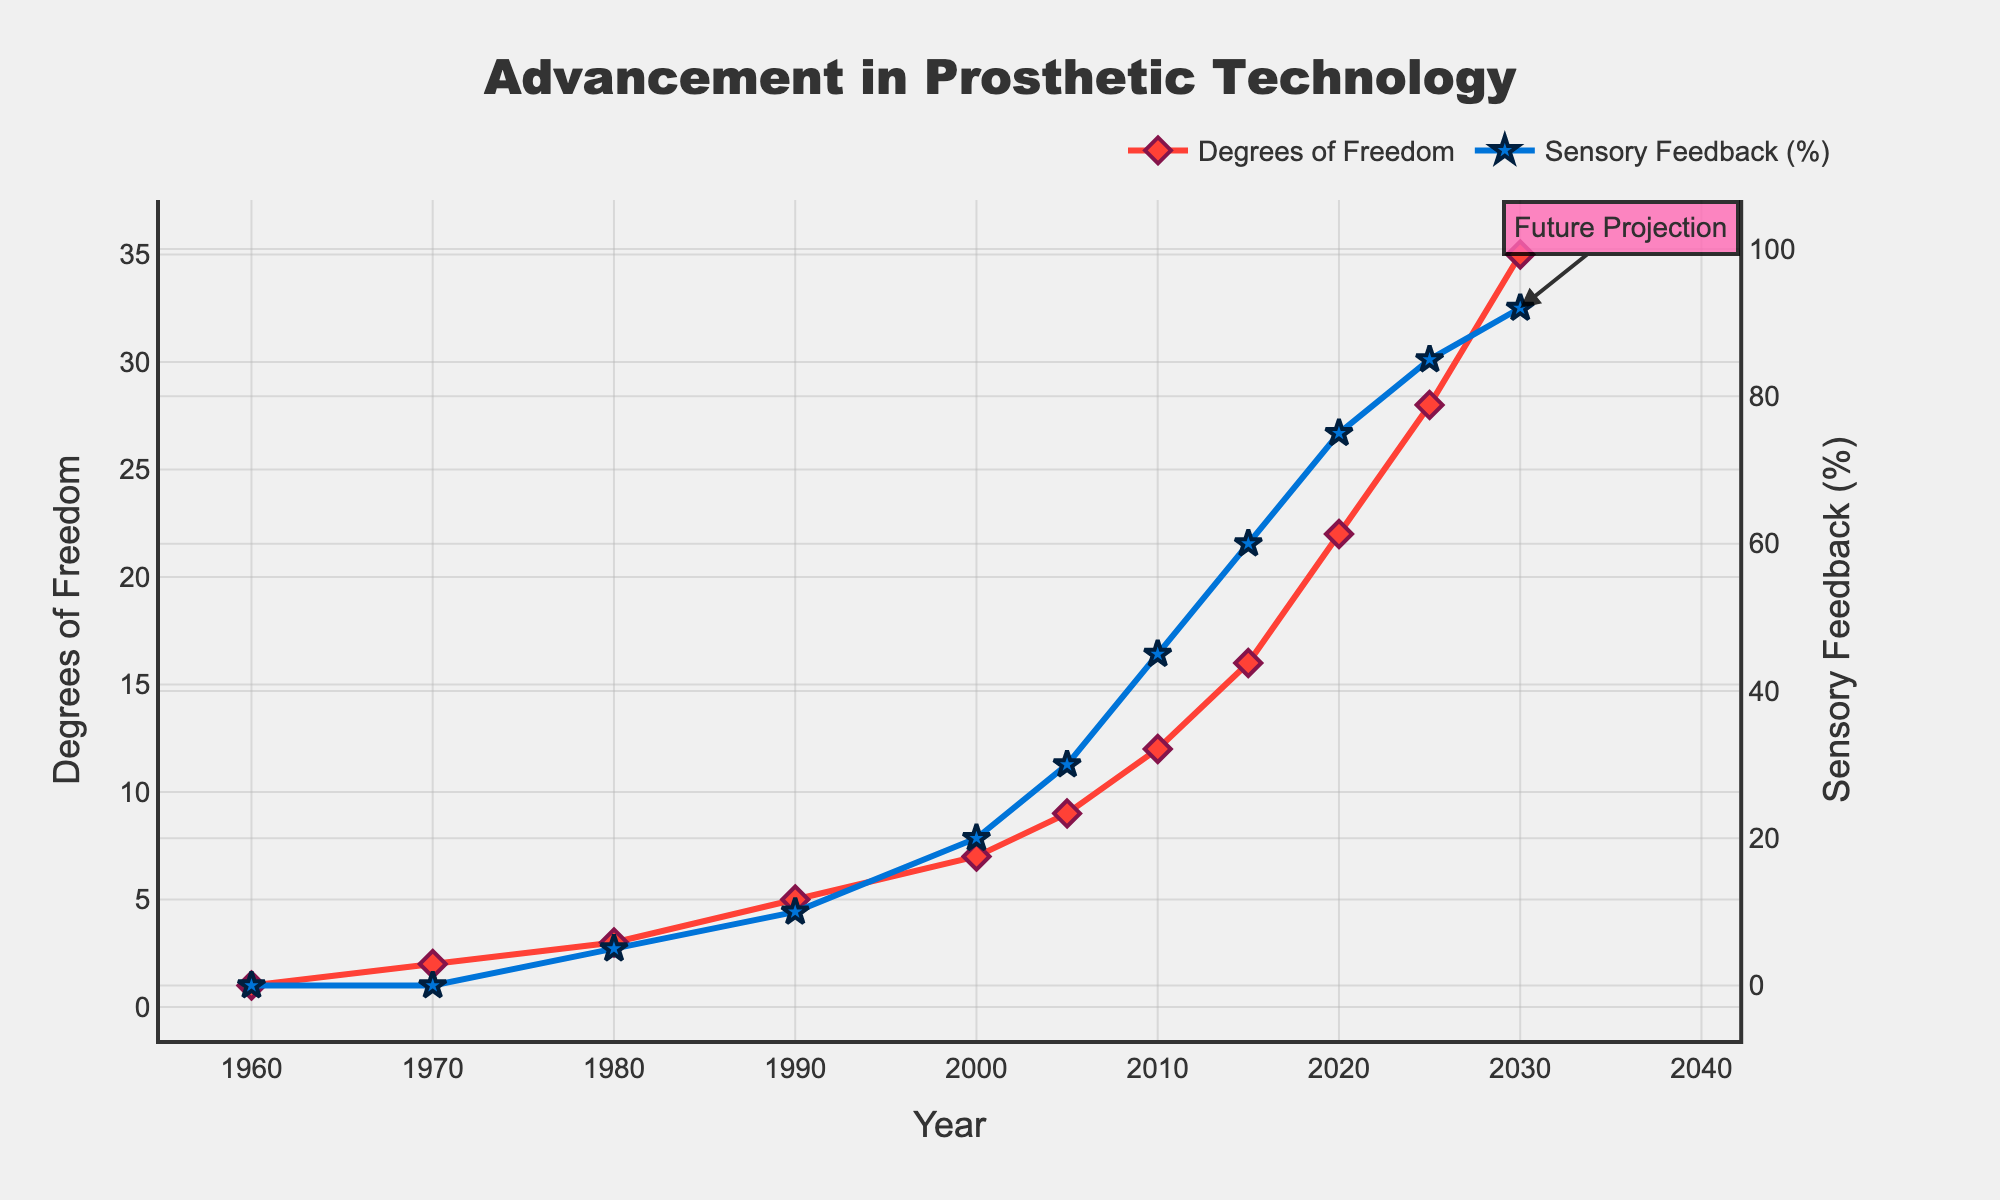When did the degree of freedom first significantly increase by more than one unit? From the chart, the Degrees of Freedom increased from 1 in 1960 to 2 in 1970. Here the increase is exactly one unit. However, from 1980 to 1990, it increased from 3 to 5, which is more than one unit.
Answer: 1980-1990 What year did Sensory Feedback reach 60% for the first time? Locate the point on the Sensory Feedback line where the value reaches 60%. This happens in 2015.
Answer: 2015 Which improved more significantly from 2000 to 2005: Degrees of Freedom or Sensory Feedback (%)? Degrees of Freedom increased from 7 to 9 (a difference of 2), while Sensory Feedback (%) increased from 20% to 30% (a difference of 10%). Comparatively, Sensory Feedback (%) had a greater increase of 10 percentage points.
Answer: Sensory Feedback (%) What is the average Degrees of Freedom between 2010 and 2025? First, identify the Degrees of Freedom values for 2010, 2015, 2020, and 2025 which are 12, 16, 22, and 28 respectively. Sum these values to get 12 + 16 + 22 + 28 = 78. Then, divide by the number of data points: 78 / 4 = 19.5.
Answer: 19.5 How many years passed between the introduction of 5 Degrees of Freedom and 16 Degrees of Freedom? From the chart, 5 Degrees of Freedom appear in 1990 and 16 Degrees of Freedom in 2015. The number of years between these points is 2015 - 1990 = 25 years.
Answer: 25 years Which year experienced an introduction of Future Projection in the chart? There is a labeled "Future Projection" annotation at the point corresponding to 2030 on the Sensory Feedback line.
Answer: 2030 When comparing 1980 and 2005, which had a higher Degrees of Freedom and by how much? From the chart, the Degrees of Freedom in 1980 is 3, and in 2005 it is 9. The difference is 9 - 3 = 6.
Answer: 2005, by 6 What is the expected Sensory Feedback (%) in 2030 according to the chart? The chart shows the Sensory Feedback (%) for 2030 as 92%.
Answer: 92% Between which two consecutive years did Degrees of Freedom see the greatest increase? The years and corresponding Degrees of Freedom values need to be compared. The largest increase between consecutive values is from 2010 (12) to 2015 (16), an increase of 4 units.
Answer: 2010-2015 What is the trend shown for both Degrees of Freedom and Sensory Feedback between 2000 and 2030? Both the Degrees of Freedom and Sensory Feedback (%) demonstrate an increasing trend over this period. Degrees of Freedom starts at 7 in 2000 and rises to 35 in 2030. Sensory Feedback starts at 20% in 2000 and rises to 92% in 2030.
Answer: Increasing 